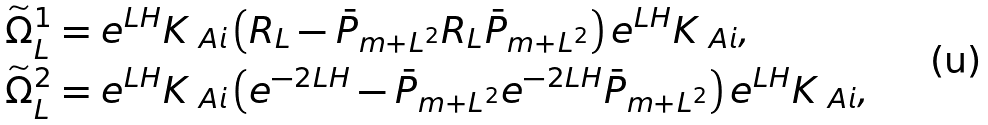<formula> <loc_0><loc_0><loc_500><loc_500>\widetilde { \Omega } ^ { 1 } _ { L } & = e ^ { L H } K _ { \ A i } \left ( R _ { L } - \bar { P } _ { m + L ^ { 2 } } R _ { L } \bar { P } _ { m + L ^ { 2 } } \right ) e ^ { L H } K _ { \ A i } , \\ \widetilde { \Omega } ^ { 2 } _ { L } & = e ^ { L H } K _ { \ A i } \left ( e ^ { - 2 L H } - \bar { P } _ { m + L ^ { 2 } } e ^ { - 2 L H } \bar { P } _ { m + L ^ { 2 } } \right ) e ^ { L H } K _ { \ A i } ,</formula> 